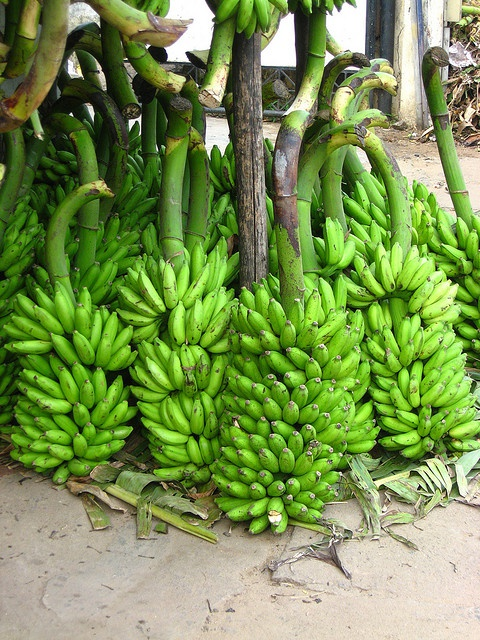Describe the objects in this image and their specific colors. I can see banana in darkgreen, green, and lightgreen tones, banana in darkgreen, green, black, and lightgreen tones, banana in darkgreen, green, lightgreen, and lime tones, banana in darkgreen, lightgreen, green, and lime tones, and banana in darkgreen, black, green, and ivory tones in this image. 